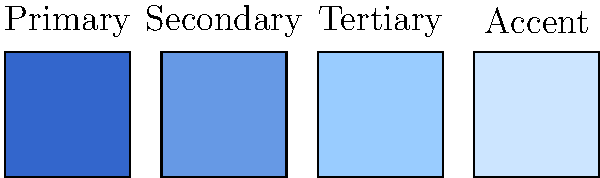Which color in the palette above would be most suitable as the main brand color for your personal project, and why is it important to choose this color carefully? 1. Analyze the color palette:
   - The palette shows four colors ranging from dark blue to light blue.
   - They are labeled as Primary, Secondary, Tertiary, and Accent.

2. Understand the importance of the primary color:
   - The primary color (darkest blue) is typically used as the main brand color.
   - It sets the tone for the entire brand identity.

3. Consider the characteristics of the primary color:
   - It's a deep, rich blue that conveys professionalism and trust.
   - This color is versatile and can work well across various applications.

4. Recognize the importance of careful color selection:
   - Colors evoke emotions and associations in viewers.
   - The right color can help communicate brand values and personality.
   - Consistency in color use builds brand recognition over time.

5. Apply to your personal project:
   - As a branding novice, choosing the primary color as your main brand color provides a solid foundation.
   - It allows for easy expansion using the other colors in the palette for various design elements.

6. Understand the role of other colors:
   - Secondary, tertiary, and accent colors complement the primary color.
   - They provide flexibility in design while maintaining a cohesive look.
Answer: Primary color (darkest blue); it sets the brand's foundation and communicates core values. 